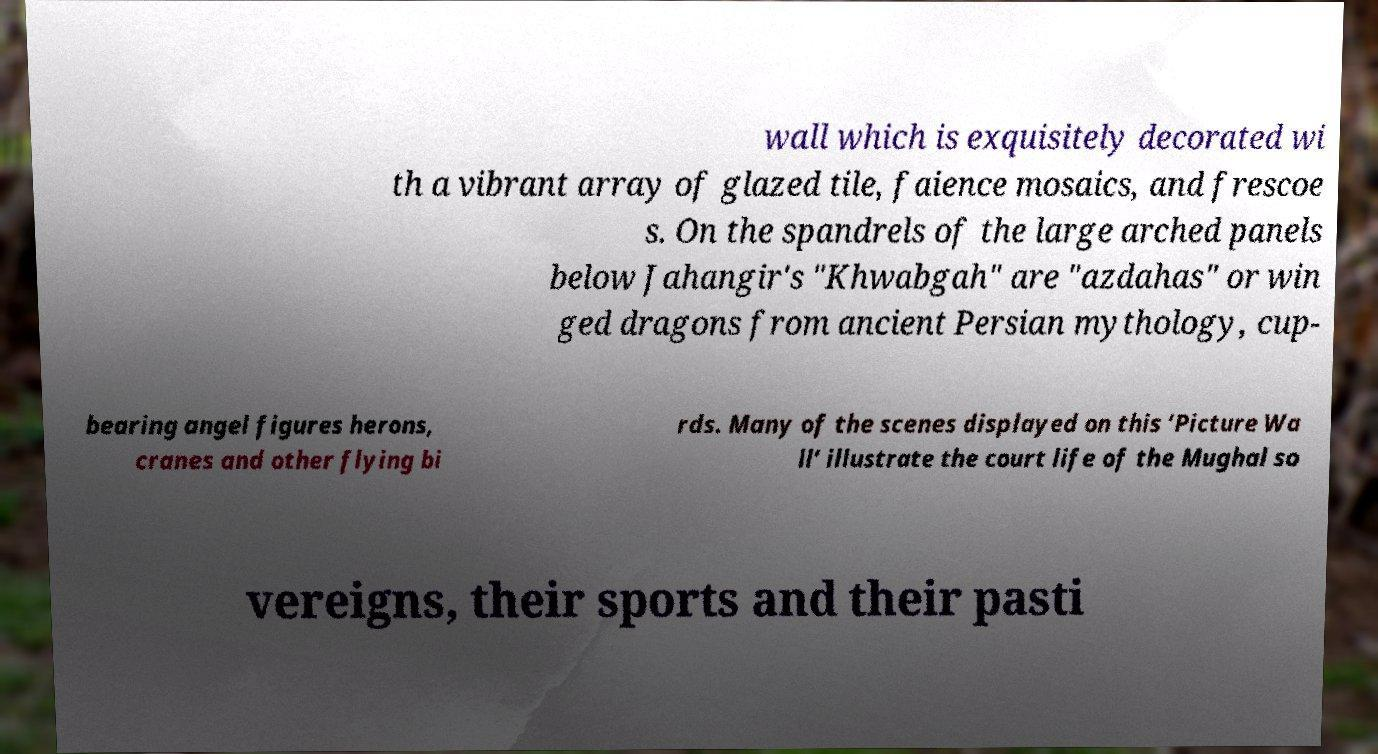What messages or text are displayed in this image? I need them in a readable, typed format. wall which is exquisitely decorated wi th a vibrant array of glazed tile, faience mosaics, and frescoe s. On the spandrels of the large arched panels below Jahangir's "Khwabgah" are "azdahas" or win ged dragons from ancient Persian mythology, cup- bearing angel figures herons, cranes and other flying bi rds. Many of the scenes displayed on this ‘Picture Wa ll’ illustrate the court life of the Mughal so vereigns, their sports and their pasti 